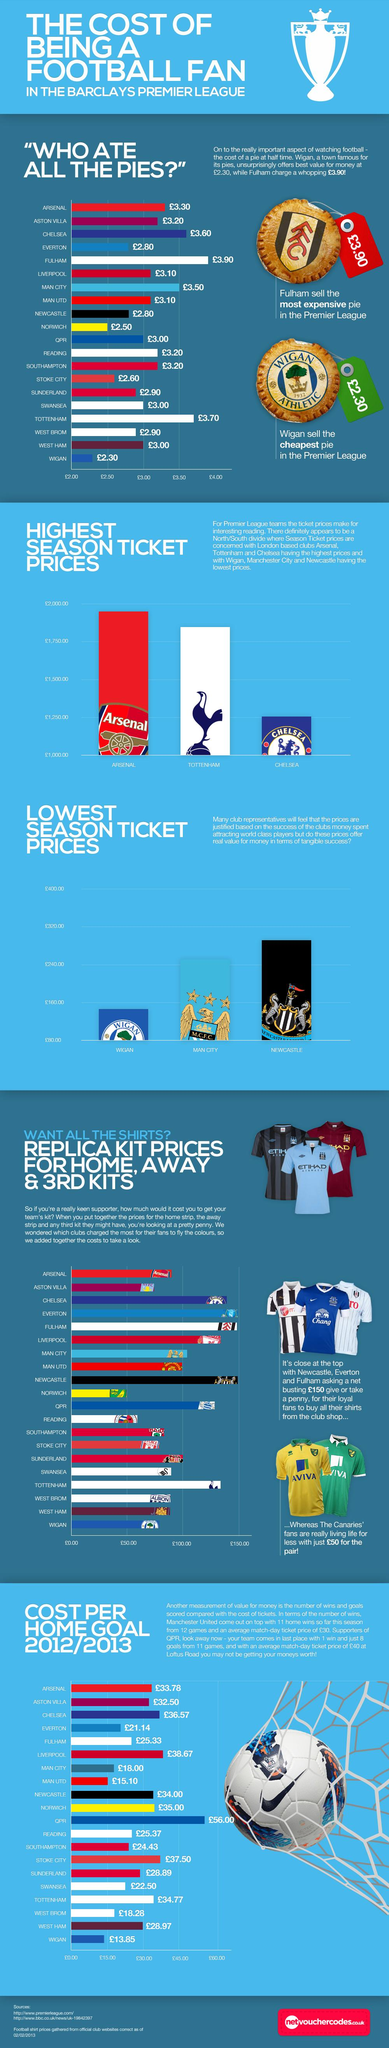Identify some key points in this picture. The pies supplied at half time, costing 3.20 pounds, were provided by Aston Villa, Reading, and Southampton. The team with the second highest season ticket prices is Tottenham. There are two sources listed at the bottom. 